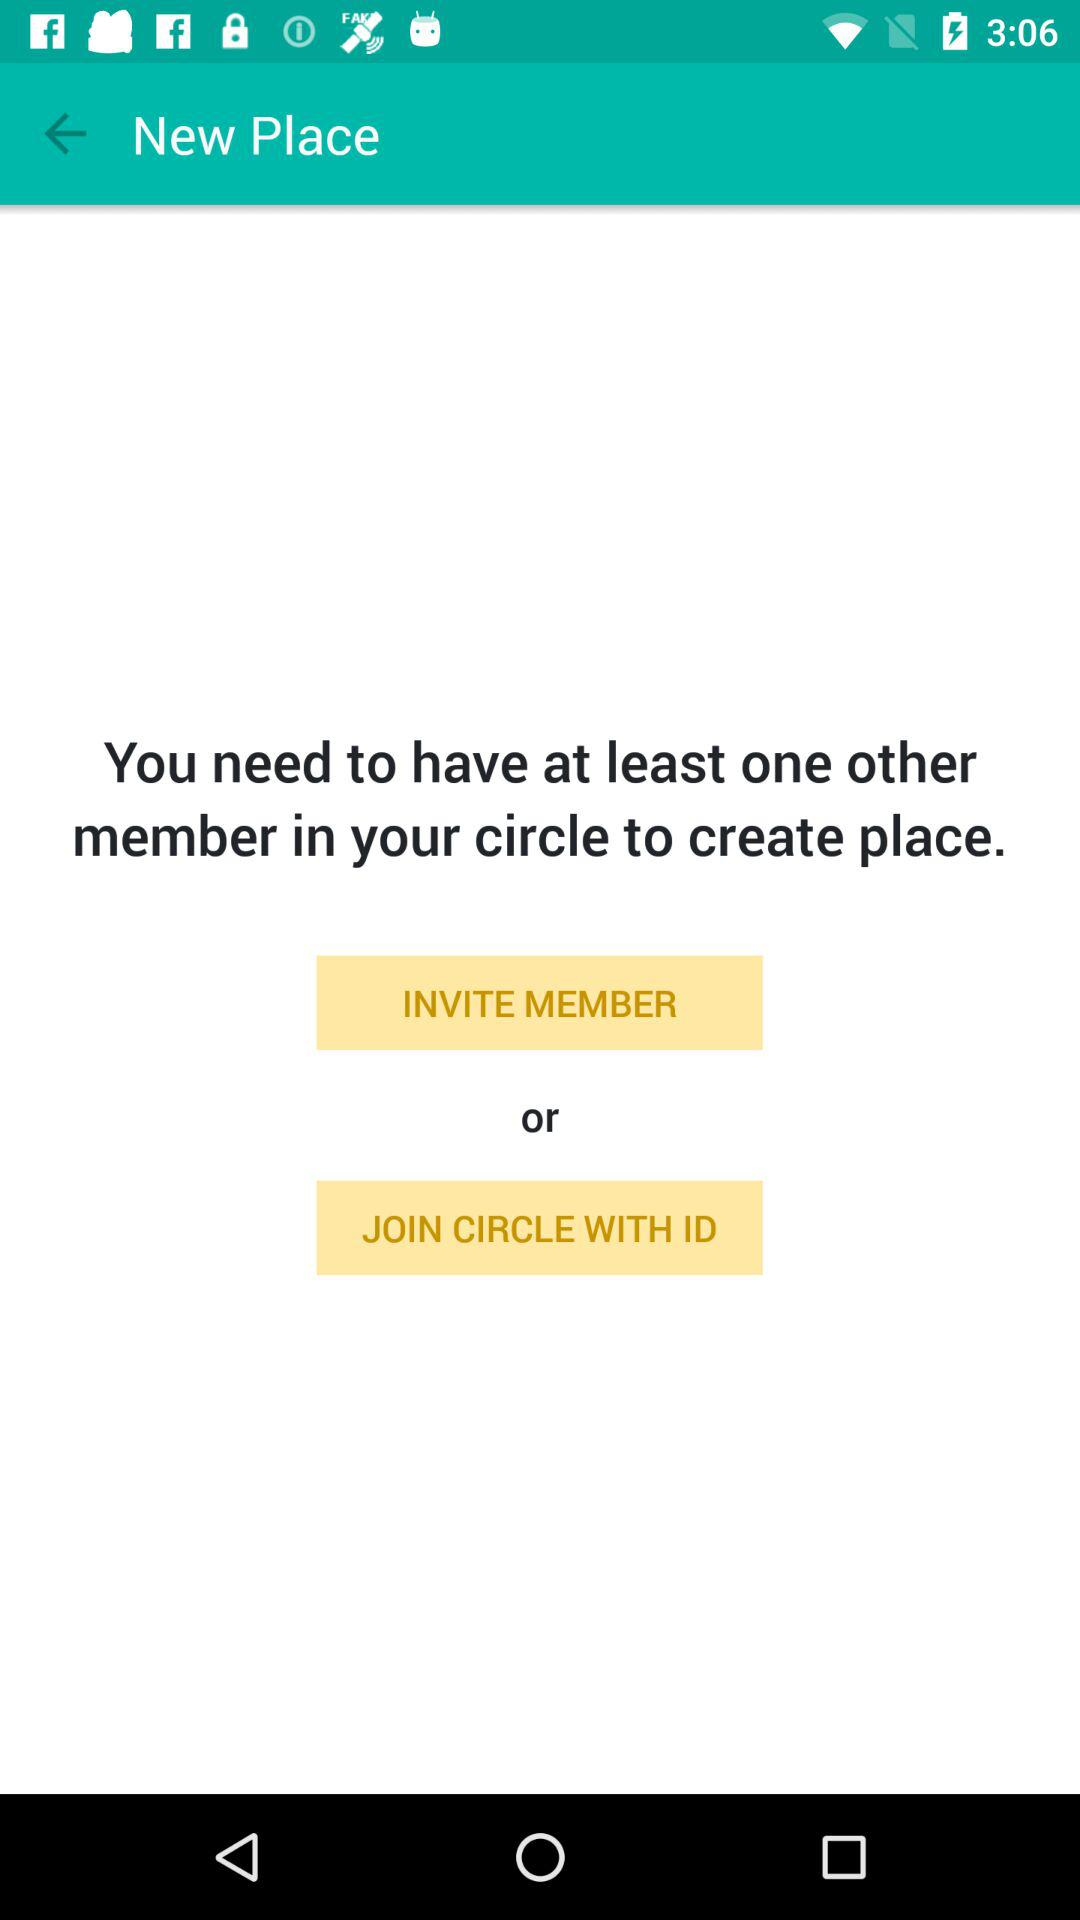How many members need to be added to the circle? The number of members that need to be added to the circle is at least one. 